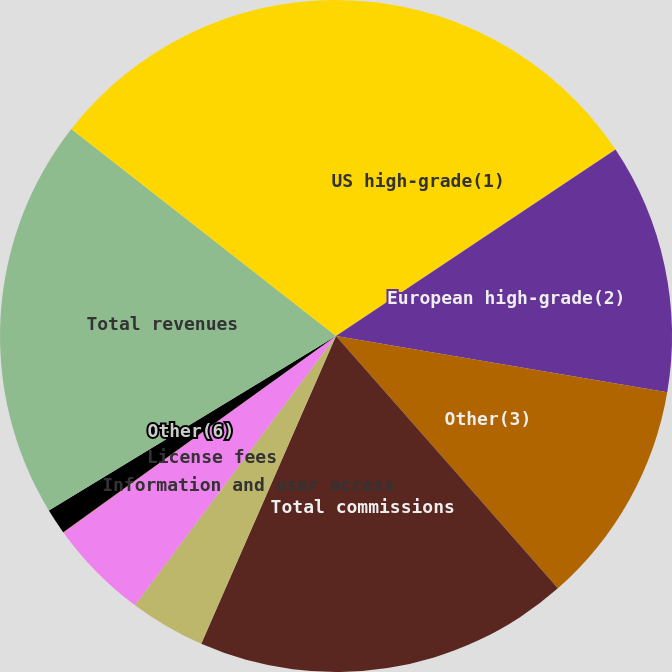<chart> <loc_0><loc_0><loc_500><loc_500><pie_chart><fcel>US high-grade(1)<fcel>European high-grade(2)<fcel>Other(3)<fcel>Total commissions<fcel>Information and user access<fcel>License fees<fcel>Interest income(5)<fcel>Other(6)<fcel>Total revenues<fcel>Employee compensation and<nl><fcel>15.64%<fcel>12.04%<fcel>10.84%<fcel>18.05%<fcel>3.64%<fcel>4.84%<fcel>0.03%<fcel>1.23%<fcel>19.25%<fcel>14.44%<nl></chart> 